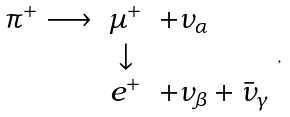Convert formula to latex. <formula><loc_0><loc_0><loc_500><loc_500>\begin{array} { r c l } \pi ^ { + } \longrightarrow & \mu ^ { + } & + \nu _ { \alpha } \\ & \downarrow & \\ & e ^ { + } & + \nu _ { \beta } + \bar { \nu } _ { \gamma } \end{array} ,</formula> 